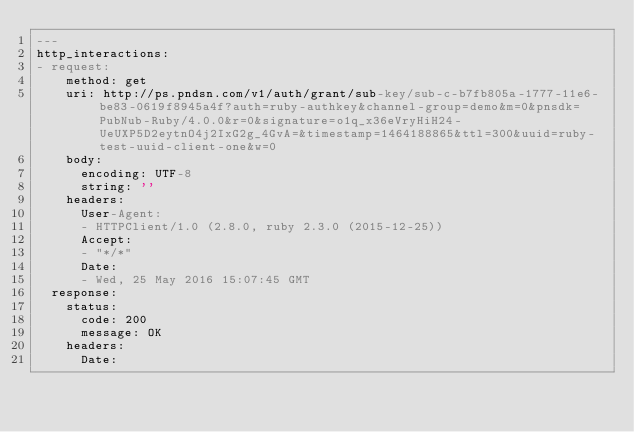Convert code to text. <code><loc_0><loc_0><loc_500><loc_500><_YAML_>---
http_interactions:
- request:
    method: get
    uri: http://ps.pndsn.com/v1/auth/grant/sub-key/sub-c-b7fb805a-1777-11e6-be83-0619f8945a4f?auth=ruby-authkey&channel-group=demo&m=0&pnsdk=PubNub-Ruby/4.0.0&r=0&signature=o1q_x36eVryHiH24-UeUXP5D2eytnO4j2IxG2g_4GvA=&timestamp=1464188865&ttl=300&uuid=ruby-test-uuid-client-one&w=0
    body:
      encoding: UTF-8
      string: ''
    headers:
      User-Agent:
      - HTTPClient/1.0 (2.8.0, ruby 2.3.0 (2015-12-25))
      Accept:
      - "*/*"
      Date:
      - Wed, 25 May 2016 15:07:45 GMT
  response:
    status:
      code: 200
      message: OK
    headers:
      Date:</code> 